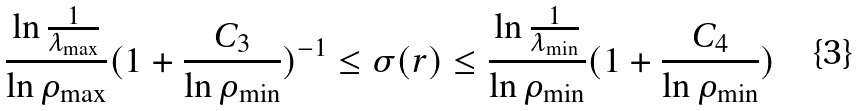Convert formula to latex. <formula><loc_0><loc_0><loc_500><loc_500>\frac { \ln \frac { 1 } { \lambda _ { \max } } } { \ln \rho _ { \max } } ( 1 + \frac { C _ { 3 } } { \ln \rho _ { \min } } ) ^ { - 1 } \leq \sigma ( r ) \leq \frac { \ln \frac { 1 } { \lambda _ { \min } } } { \ln \rho _ { \min } } ( 1 + \frac { C _ { 4 } } { \ln \rho _ { \min } } )</formula> 